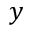<formula> <loc_0><loc_0><loc_500><loc_500>y</formula> 